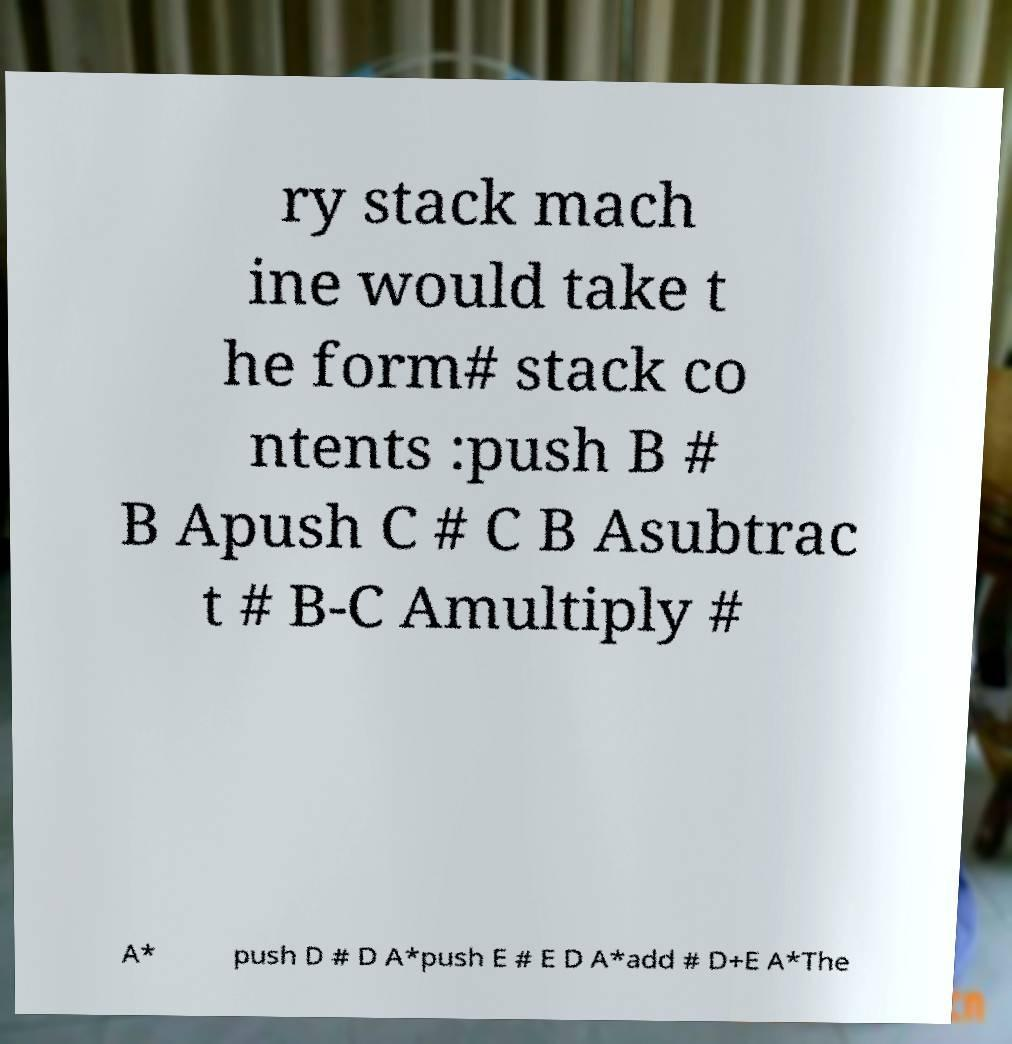What messages or text are displayed in this image? I need them in a readable, typed format. ry stack mach ine would take t he form# stack co ntents :push B # B Apush C # C B Asubtrac t # B-C Amultiply # A* push D # D A*push E # E D A*add # D+E A*The 